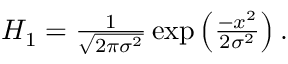<formula> <loc_0><loc_0><loc_500><loc_500>\begin{array} { r } { H _ { 1 } = \frac { 1 } { \sqrt { 2 \pi \sigma ^ { 2 } } } \exp \left ( \frac { - x ^ { 2 } } { 2 \sigma ^ { 2 } } \right ) . } \end{array}</formula> 